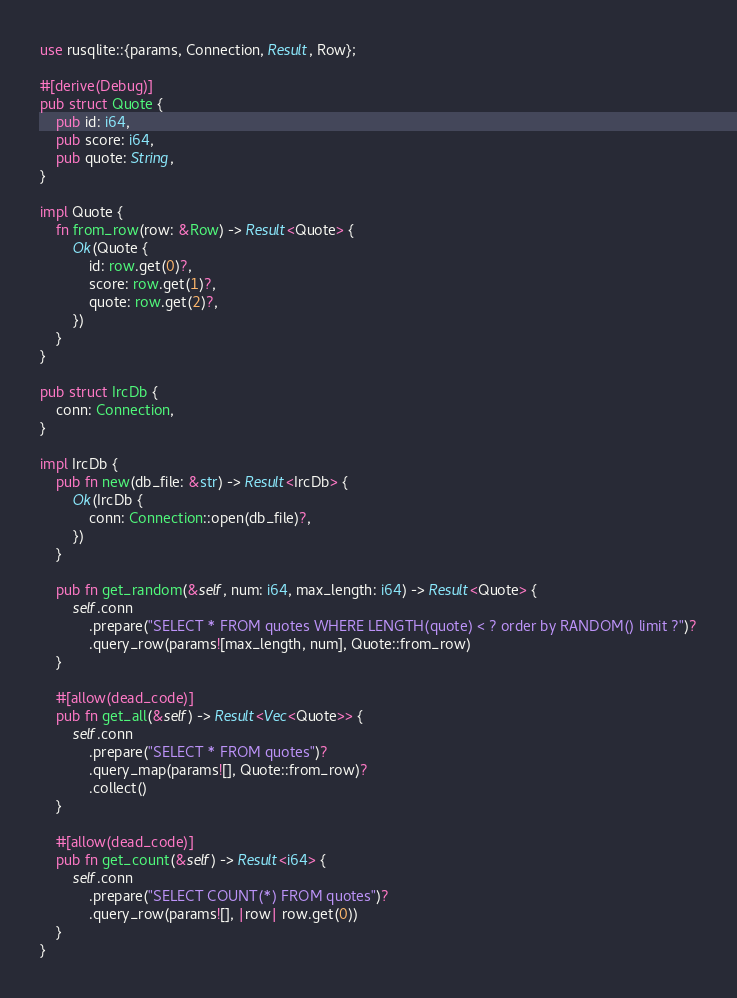<code> <loc_0><loc_0><loc_500><loc_500><_Rust_>use rusqlite::{params, Connection, Result, Row};

#[derive(Debug)]
pub struct Quote {
    pub id: i64,
    pub score: i64,
    pub quote: String,
}

impl Quote {
    fn from_row(row: &Row) -> Result<Quote> {
        Ok(Quote {
            id: row.get(0)?,
            score: row.get(1)?,
            quote: row.get(2)?,
        })
    }
}

pub struct IrcDb {
    conn: Connection,
}

impl IrcDb {
    pub fn new(db_file: &str) -> Result<IrcDb> {
        Ok(IrcDb {
            conn: Connection::open(db_file)?,
        })
    }

    pub fn get_random(&self, num: i64, max_length: i64) -> Result<Quote> {
        self.conn
            .prepare("SELECT * FROM quotes WHERE LENGTH(quote) < ? order by RANDOM() limit ?")?
            .query_row(params![max_length, num], Quote::from_row)
    }

    #[allow(dead_code)]
    pub fn get_all(&self) -> Result<Vec<Quote>> {
        self.conn
            .prepare("SELECT * FROM quotes")?
            .query_map(params![], Quote::from_row)?
            .collect()
    }

    #[allow(dead_code)]
    pub fn get_count(&self) -> Result<i64> {
        self.conn
            .prepare("SELECT COUNT(*) FROM quotes")?
            .query_row(params![], |row| row.get(0))
    }
}
</code> 